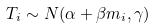<formula> <loc_0><loc_0><loc_500><loc_500>T _ { i } \sim N ( \alpha + \beta m _ { i } , \gamma )</formula> 